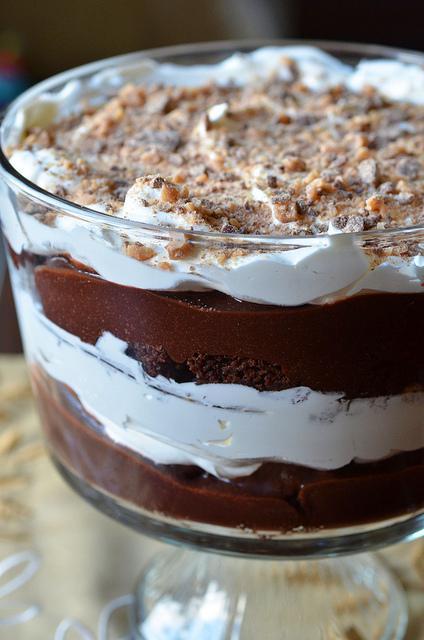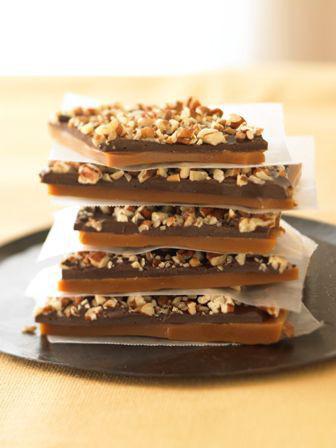The first image is the image on the left, the second image is the image on the right. Examine the images to the left and right. Is the description "Both of the trifles are in glass dishes with stands." accurate? Answer yes or no. No. 